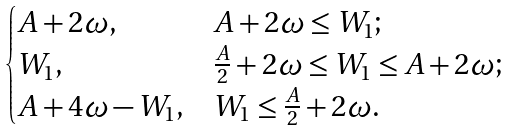Convert formula to latex. <formula><loc_0><loc_0><loc_500><loc_500>\begin{cases} A + 2 \omega , & A + 2 \omega \leq W _ { 1 } ; \\ W _ { 1 } , & \frac { A } { 2 } + 2 \omega \leq W _ { 1 } \leq A + 2 \omega ; \\ A + 4 \omega - W _ { 1 } , & W _ { 1 } \leq \frac { A } { 2 } + 2 \omega . \\ \end{cases}</formula> 